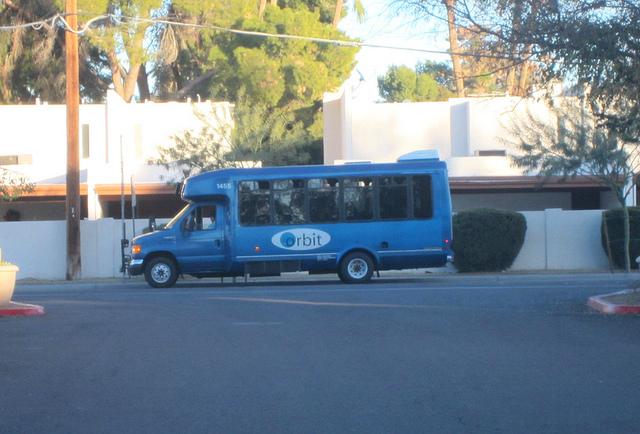What is the name on the bus?
Answer briefly. Orbit. Is this a bus?
Short answer required. Yes. Is the road paved?
Be succinct. Yes. 